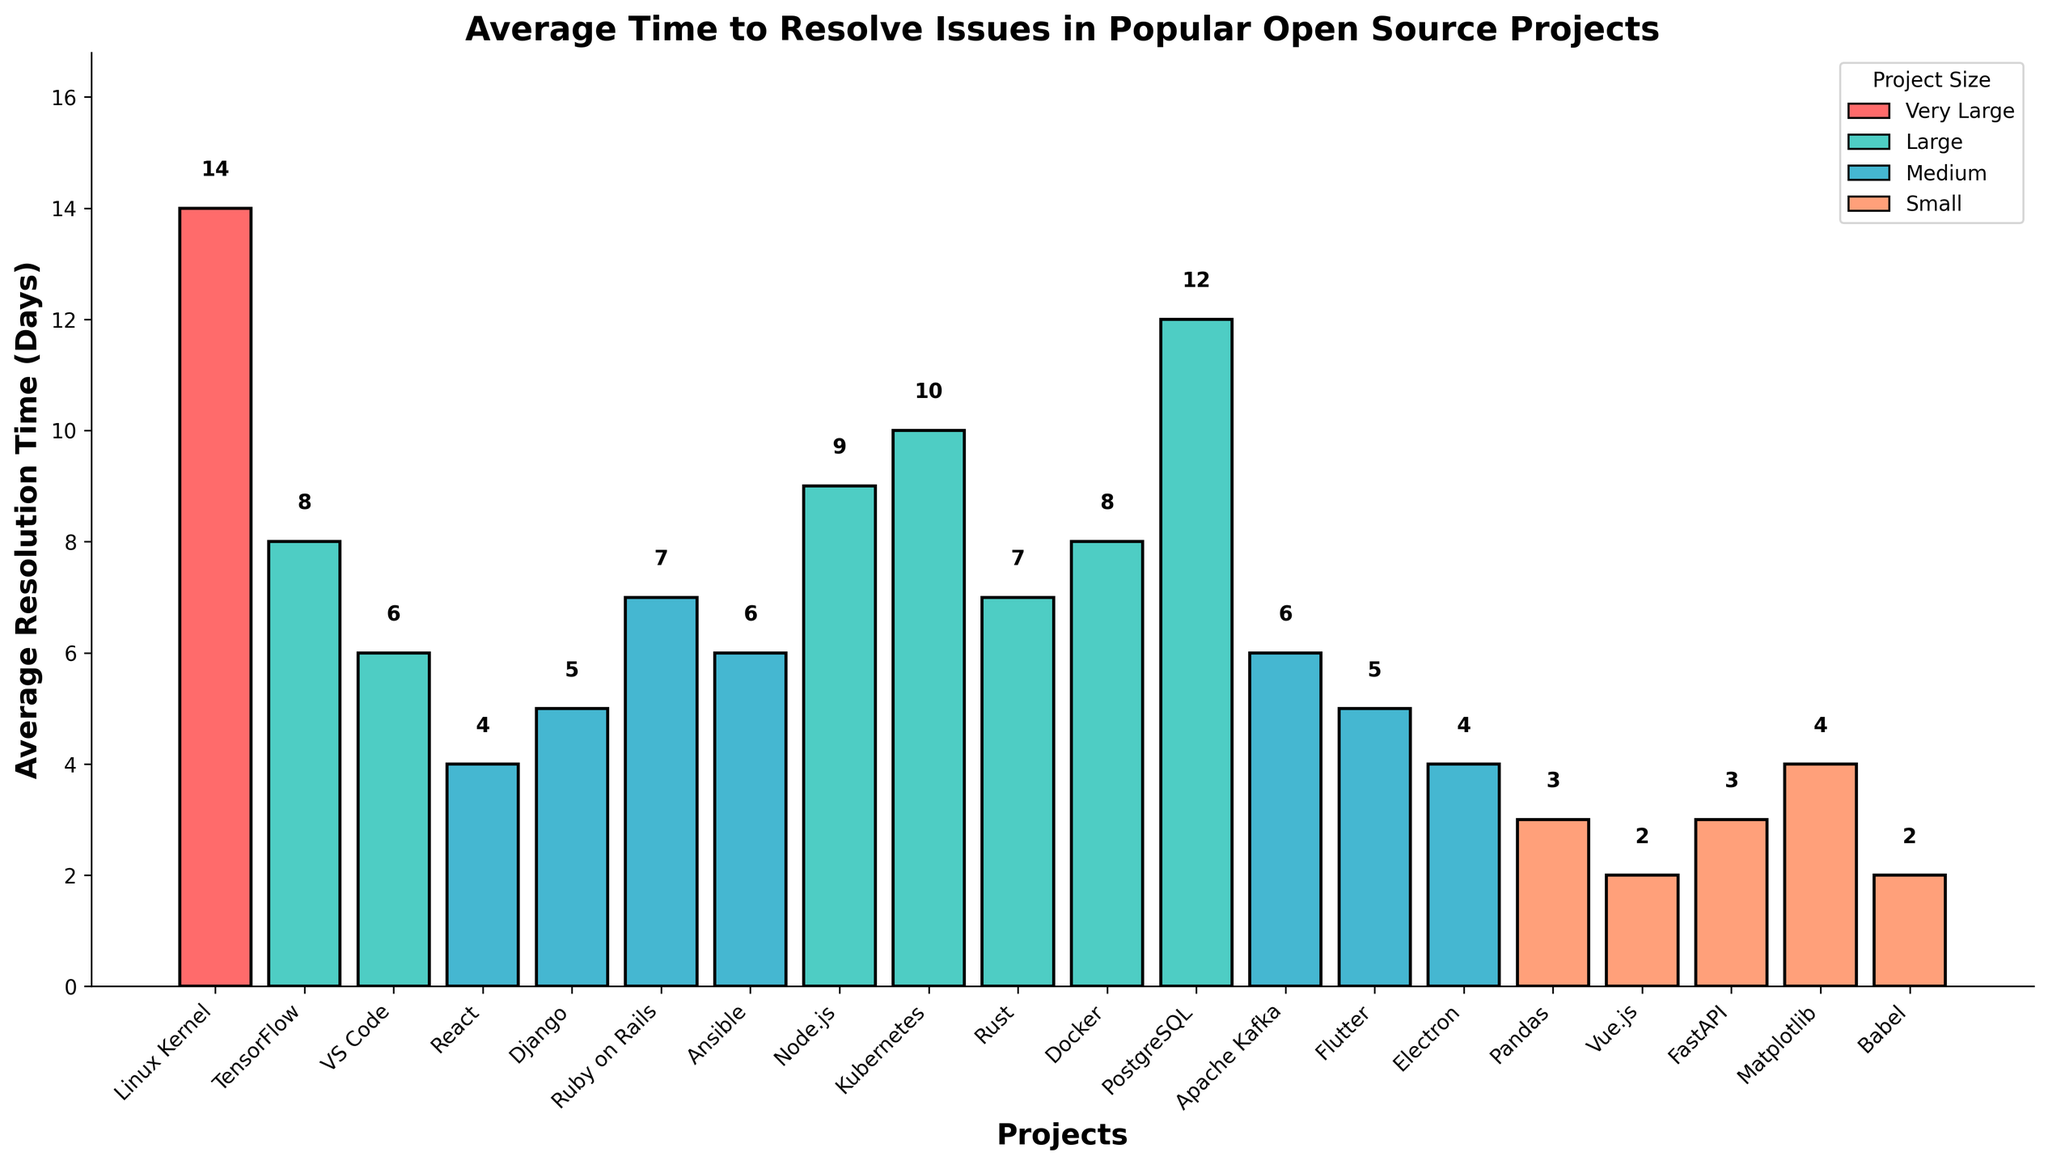Which project has the shortest average resolution time? Look at the bar chart to identify which bar is the shortest, indicative of the project with the shortest average resolution time. The shortest bar corresponds to Vue.js.
Answer: Vue.js Which project category has the highest average resolution time? Look at the color-coded bars and identify the tallest bar. The tallest bar is for the 'Very Large' project group, specifically the Linux Kernel.
Answer: Very Large What is the difference in average resolution time between Node.js and Django? Find the average resolution times for Node.js (9 days) and Django (5 days). Calculate the difference: 9 - 5 = 4 days.
Answer: 4 days Which projects fall into the 'Medium' size category and what is their range of average resolution times? Identify the bars colored for 'Medium' projects. The 'Medium' projects and their resolution times are: React (4 days), Django (5 days), Ruby on Rails (7 days), Ansible (6 days), Apache Kafka (6 days), Flutter (5 days), and Electron (4 days). The range is 7 - 4 = 3 days.
Answer: React, Django, Ruby on Rails, Ansible, Apache Kafka, Flutter, Electron; 3 days Which project has an average resolution time greater than Docker but less than PostgreSQL? Docker has an average resolution time of 8 days and PostgreSQL has 12 days. Identify the bars between these values. Kubernetes (10 days) fits this range.
Answer: Kubernetes How many projects have an average resolution time of less than 5 days? Examine the bars to find those with values under 5 days. The projects are React (4 days), Electron (4 days), Vue.js (2 days), FastAPI (3 days), Pandas (3 days), and Babel (2 days). Count them: 6 projects.
Answer: 6 projects What is the average resolution time for projects in the 'Large' size category? Identify the 'Large' projects: TensorFlow (8 days), VS Code (6 days), Node.js (9 days), Kubernetes (10 days), Rust (7 days), and Docker (8 days), PostgreSQL (12 days). Calculate the average: (8 + 6 + 9 + 10 + 7 + 8 + 12) / 7 = 8.57 days.
Answer: 8.57 days Is the average resolution time for 'Small' projects generally higher or lower than 'Medium' projects? Compare the average resolution times for all 'Small' projects (Vue.js, Pandas, FastAPI, Matplotlib, Babel) and 'Medium' projects (React, Django, Ruby on Rails, Ansible, Apache Kafka, Flutter, Electron). Notice that 'Small' projects generally have lower resolution times (2-4 days) compared to 'Medium' projects (4-7 days).
Answer: Lower 